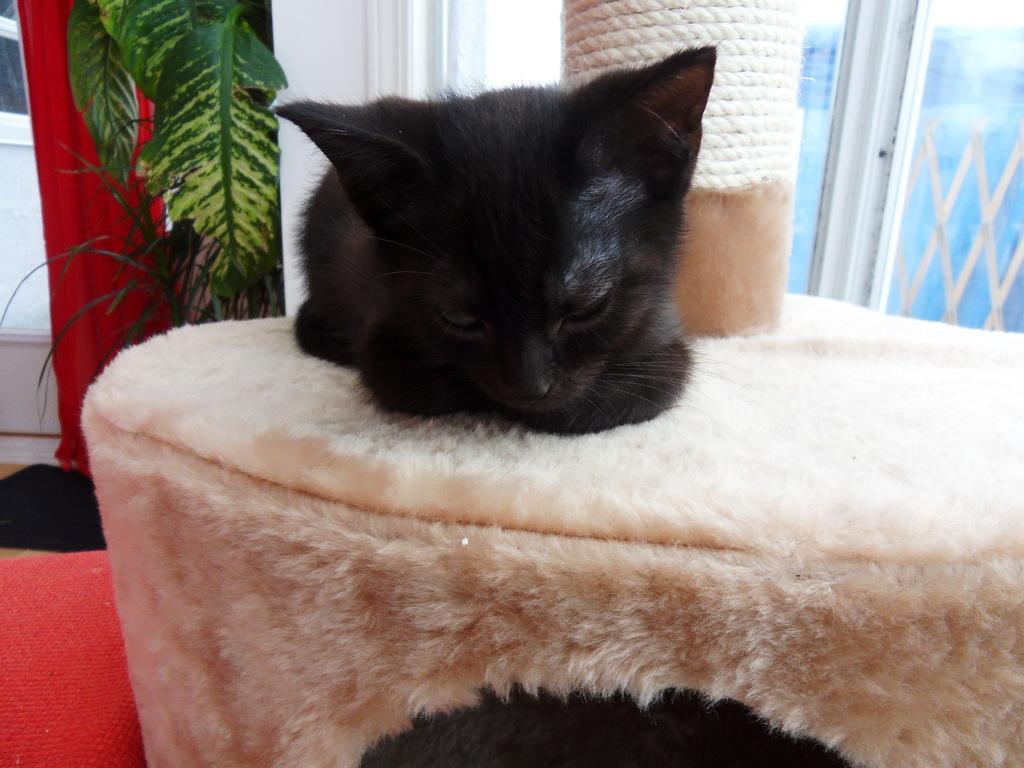Describe this image in one or two sentences. In this picture I can see a cat in the middle, on the left side there are plants. On the right side it looks like a glass window. 